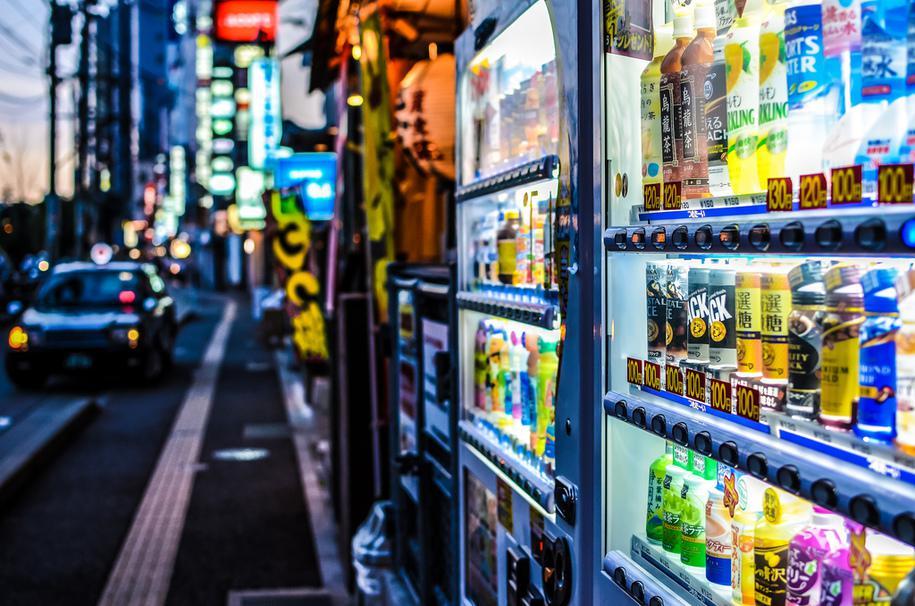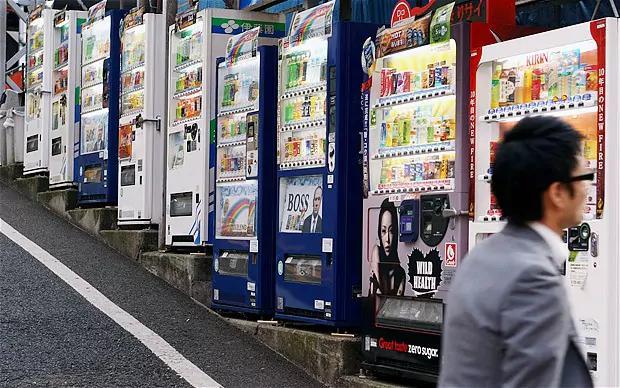The first image is the image on the left, the second image is the image on the right. Considering the images on both sides, is "At least one person is near the machines in the image on the right." valid? Answer yes or no. Yes. The first image is the image on the left, the second image is the image on the right. For the images displayed, is the sentence "In the right image, there is no less than one person standing in front of and staring ahead at a row of vending machines" factually correct? Answer yes or no. Yes. 